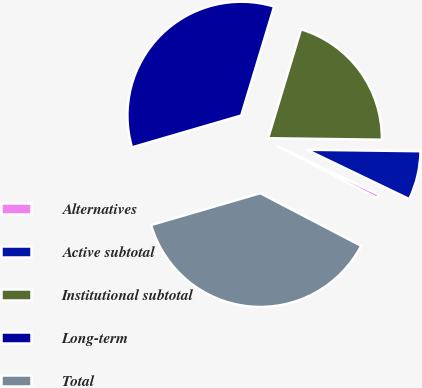<chart> <loc_0><loc_0><loc_500><loc_500><pie_chart><fcel>Alternatives<fcel>Active subtotal<fcel>Institutional subtotal<fcel>Long-term<fcel>Total<nl><fcel>0.52%<fcel>6.93%<fcel>20.54%<fcel>34.19%<fcel>37.83%<nl></chart> 